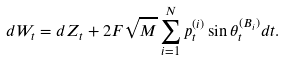Convert formula to latex. <formula><loc_0><loc_0><loc_500><loc_500>d W _ { t } = d Z _ { t } + 2 F \sqrt { M } \sum _ { i = 1 } ^ { N } p _ { t } ^ { ( i ) } \sin { \theta _ { t } ^ { ( B _ { i } ) } } d t .</formula> 